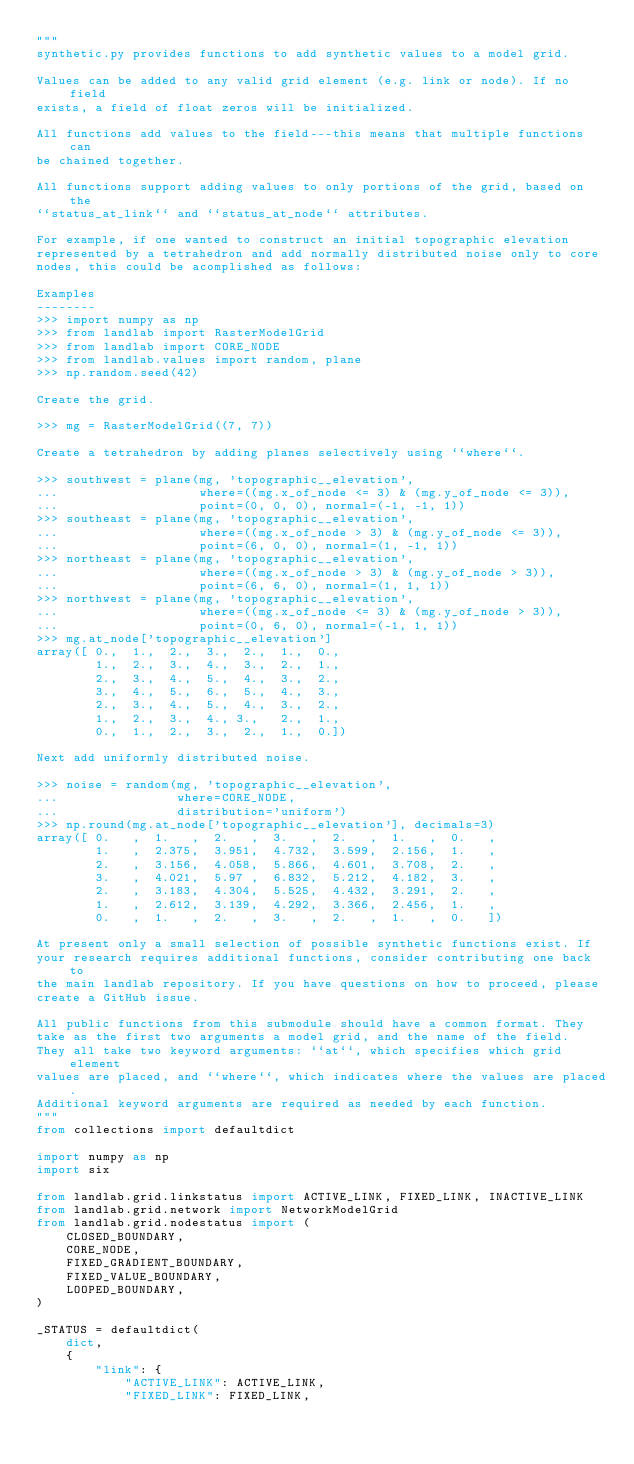<code> <loc_0><loc_0><loc_500><loc_500><_Python_>"""
synthetic.py provides functions to add synthetic values to a model grid.

Values can be added to any valid grid element (e.g. link or node). If no field
exists, a field of float zeros will be initialized.

All functions add values to the field---this means that multiple functions can
be chained together.

All functions support adding values to only portions of the grid, based on the
``status_at_link`` and ``status_at_node`` attributes.

For example, if one wanted to construct an initial topographic elevation
represented by a tetrahedron and add normally distributed noise only to core
nodes, this could be acomplished as follows:

Examples
--------
>>> import numpy as np
>>> from landlab import RasterModelGrid
>>> from landlab import CORE_NODE
>>> from landlab.values import random, plane
>>> np.random.seed(42)

Create the grid.

>>> mg = RasterModelGrid((7, 7))

Create a tetrahedron by adding planes selectively using ``where``.

>>> southwest = plane(mg, 'topographic__elevation',
...                   where=((mg.x_of_node <= 3) & (mg.y_of_node <= 3)),
...                   point=(0, 0, 0), normal=(-1, -1, 1))
>>> southeast = plane(mg, 'topographic__elevation',
...                   where=((mg.x_of_node > 3) & (mg.y_of_node <= 3)),
...                   point=(6, 0, 0), normal=(1, -1, 1))
>>> northeast = plane(mg, 'topographic__elevation',
...                   where=((mg.x_of_node > 3) & (mg.y_of_node > 3)),
...                   point=(6, 6, 0), normal=(1, 1, 1))
>>> northwest = plane(mg, 'topographic__elevation',
...                   where=((mg.x_of_node <= 3) & (mg.y_of_node > 3)),
...                   point=(0, 6, 0), normal=(-1, 1, 1))
>>> mg.at_node['topographic__elevation']
array([ 0.,  1.,  2.,  3.,  2.,  1.,  0.,
        1.,  2.,  3.,  4.,  3.,  2.,  1.,
        2.,  3.,  4.,  5.,  4.,  3.,  2.,
        3.,  4.,  5.,  6.,  5.,  4.,  3.,
        2.,  3.,  4.,  5.,  4.,  3.,  2.,
        1.,  2.,  3.,  4., 3.,   2.,  1.,
        0.,  1.,  2.,  3.,  2.,  1.,  0.])

Next add uniformly distributed noise.

>>> noise = random(mg, 'topographic__elevation',
...                where=CORE_NODE,
...                distribution='uniform')
>>> np.round(mg.at_node['topographic__elevation'], decimals=3)
array([ 0.   ,  1.   ,  2.   ,  3.   ,  2.   ,  1.   ,  0.   ,
        1.   ,  2.375,  3.951,  4.732,  3.599,  2.156,  1.   ,
        2.   ,  3.156,  4.058,  5.866,  4.601,  3.708,  2.   ,
        3.   ,  4.021,  5.97 ,  6.832,  5.212,  4.182,  3.   ,
        2.   ,  3.183,  4.304,  5.525,  4.432,  3.291,  2.   ,
        1.   ,  2.612,  3.139,  4.292,  3.366,  2.456,  1.   ,
        0.   ,  1.   ,  2.   ,  3.   ,  2.   ,  1.   ,  0.   ])

At present only a small selection of possible synthetic functions exist. If
your research requires additional functions, consider contributing one back to
the main landlab repository. If you have questions on how to proceed, please
create a GitHub issue.

All public functions from this submodule should have a common format. They
take as the first two arguments a model grid, and the name of the field.
They all take two keyword arguments: ``at``, which specifies which grid element
values are placed, and ``where``, which indicates where the values are placed.
Additional keyword arguments are required as needed by each function.
"""
from collections import defaultdict

import numpy as np
import six

from landlab.grid.linkstatus import ACTIVE_LINK, FIXED_LINK, INACTIVE_LINK
from landlab.grid.network import NetworkModelGrid
from landlab.grid.nodestatus import (
    CLOSED_BOUNDARY,
    CORE_NODE,
    FIXED_GRADIENT_BOUNDARY,
    FIXED_VALUE_BOUNDARY,
    LOOPED_BOUNDARY,
)

_STATUS = defaultdict(
    dict,
    {
        "link": {
            "ACTIVE_LINK": ACTIVE_LINK,
            "FIXED_LINK": FIXED_LINK,</code> 